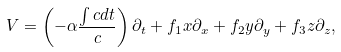Convert formula to latex. <formula><loc_0><loc_0><loc_500><loc_500>V = \left ( - \alpha \frac { \int c d t } { c } \right ) \partial _ { t } + f _ { 1 } x \partial _ { x } + f _ { 2 } y \partial _ { y } + f _ { 3 } z \partial _ { z } ,</formula> 